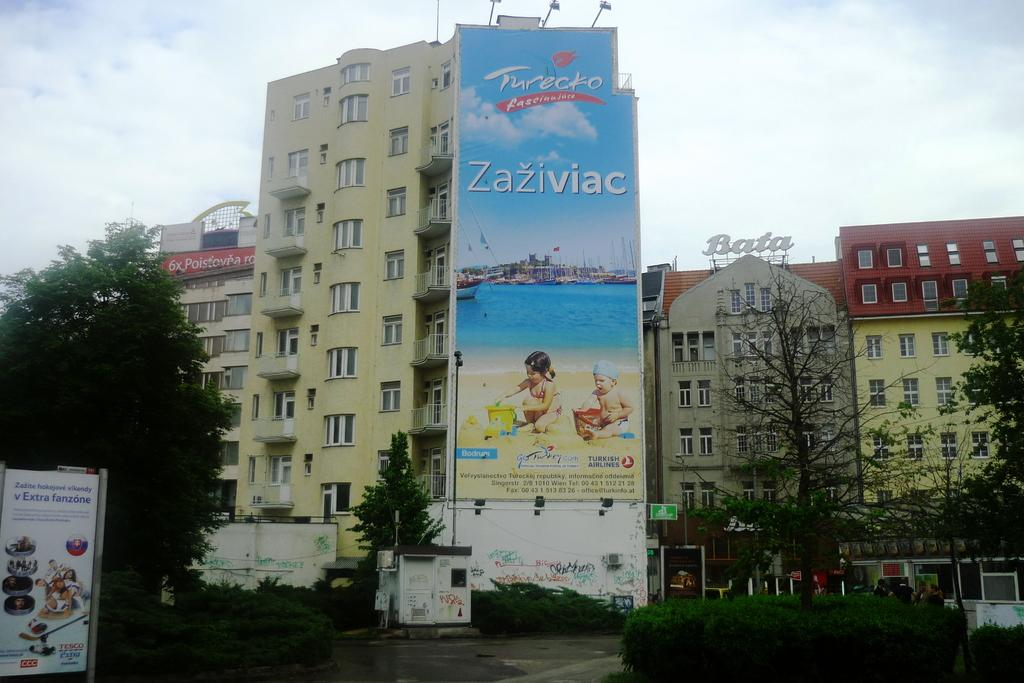<image>
Render a clear and concise summary of the photo. A large billboard on the side of  a high-rise building on which is written Zaziviac. 